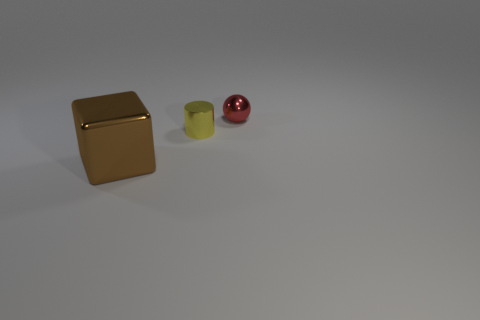Add 2 large red rubber cylinders. How many objects exist? 5 Subtract 1 cylinders. How many cylinders are left? 0 Subtract all cylinders. How many objects are left? 2 Subtract all purple metallic cylinders. Subtract all metallic spheres. How many objects are left? 2 Add 1 large objects. How many large objects are left? 2 Add 1 large gray metallic cylinders. How many large gray metallic cylinders exist? 1 Subtract 0 brown spheres. How many objects are left? 3 Subtract all gray balls. Subtract all gray cylinders. How many balls are left? 1 Subtract all green balls. How many blue cubes are left? 0 